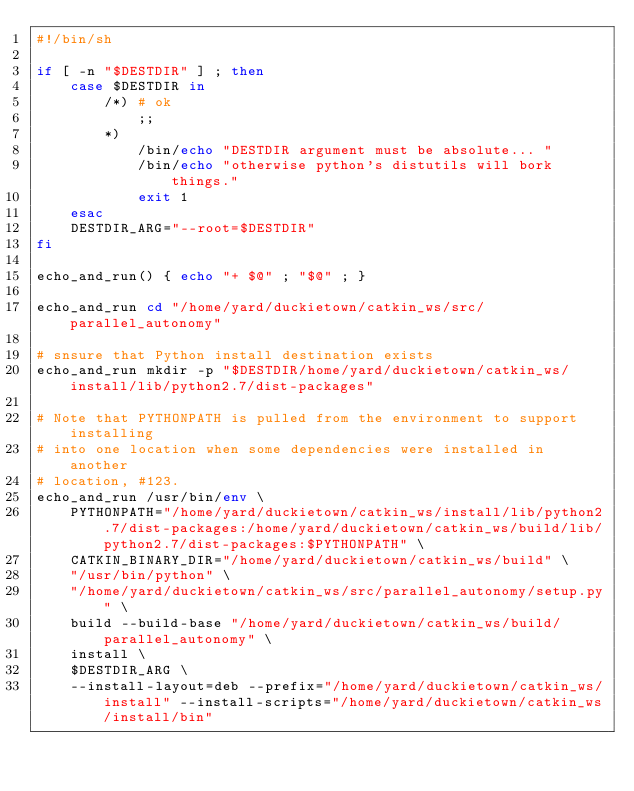<code> <loc_0><loc_0><loc_500><loc_500><_Bash_>#!/bin/sh

if [ -n "$DESTDIR" ] ; then
    case $DESTDIR in
        /*) # ok
            ;;
        *)
            /bin/echo "DESTDIR argument must be absolute... "
            /bin/echo "otherwise python's distutils will bork things."
            exit 1
    esac
    DESTDIR_ARG="--root=$DESTDIR"
fi

echo_and_run() { echo "+ $@" ; "$@" ; }

echo_and_run cd "/home/yard/duckietown/catkin_ws/src/parallel_autonomy"

# snsure that Python install destination exists
echo_and_run mkdir -p "$DESTDIR/home/yard/duckietown/catkin_ws/install/lib/python2.7/dist-packages"

# Note that PYTHONPATH is pulled from the environment to support installing
# into one location when some dependencies were installed in another
# location, #123.
echo_and_run /usr/bin/env \
    PYTHONPATH="/home/yard/duckietown/catkin_ws/install/lib/python2.7/dist-packages:/home/yard/duckietown/catkin_ws/build/lib/python2.7/dist-packages:$PYTHONPATH" \
    CATKIN_BINARY_DIR="/home/yard/duckietown/catkin_ws/build" \
    "/usr/bin/python" \
    "/home/yard/duckietown/catkin_ws/src/parallel_autonomy/setup.py" \
    build --build-base "/home/yard/duckietown/catkin_ws/build/parallel_autonomy" \
    install \
    $DESTDIR_ARG \
    --install-layout=deb --prefix="/home/yard/duckietown/catkin_ws/install" --install-scripts="/home/yard/duckietown/catkin_ws/install/bin"
</code> 